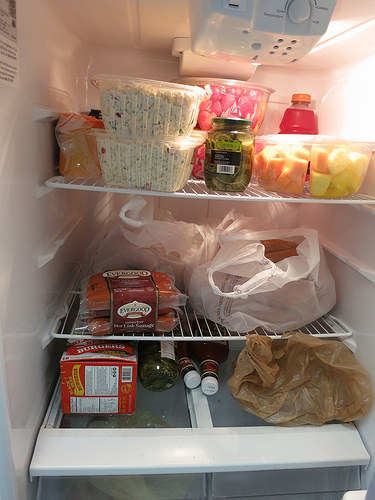<image>
Is the hot dogs under the pickles? Yes. The hot dogs is positioned underneath the pickles, with the pickles above it in the vertical space. 